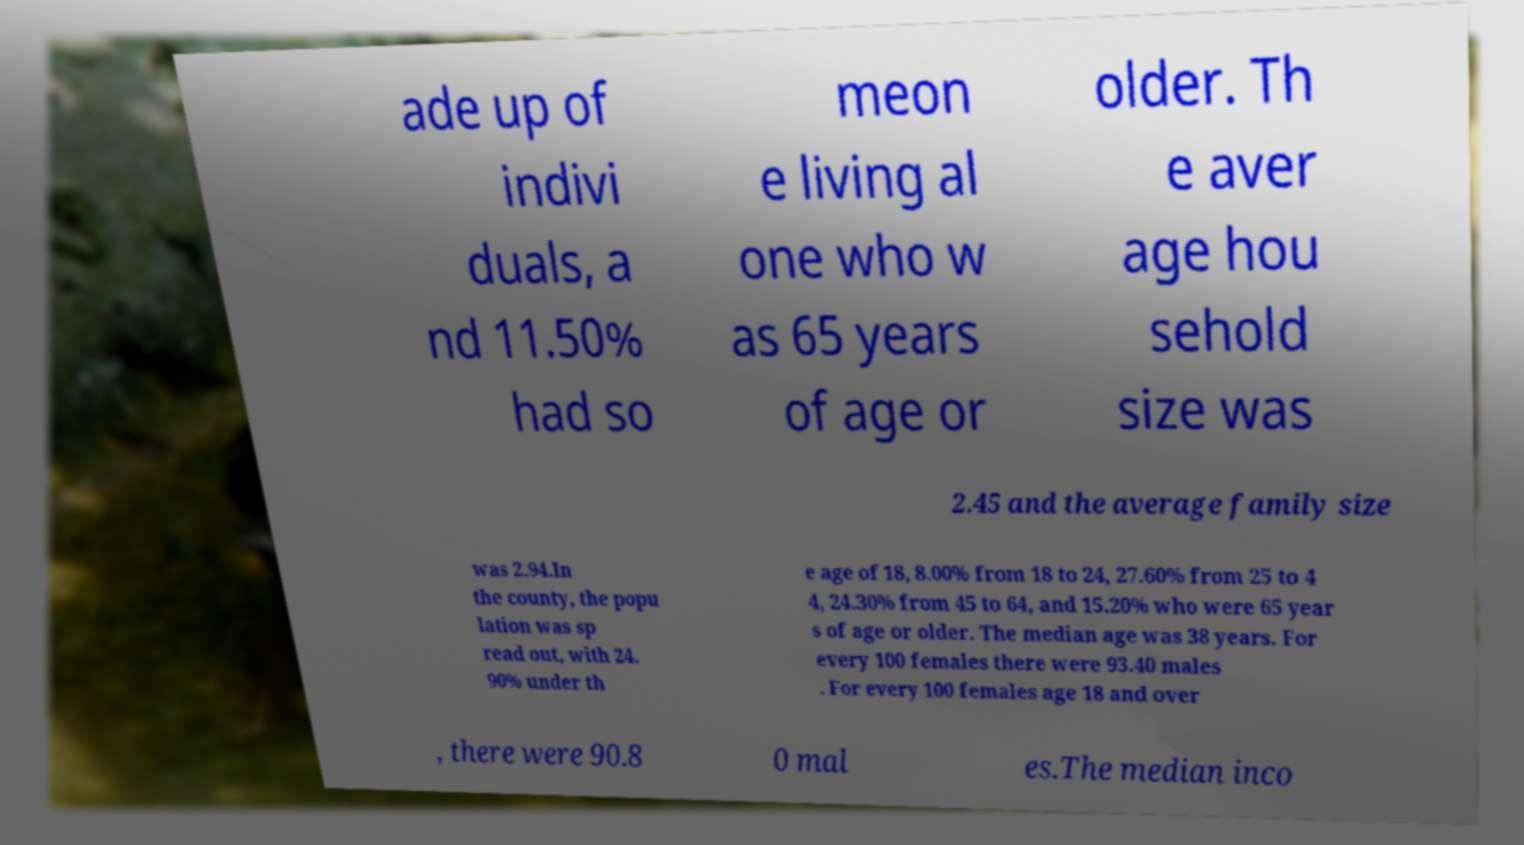What messages or text are displayed in this image? I need them in a readable, typed format. ade up of indivi duals, a nd 11.50% had so meon e living al one who w as 65 years of age or older. Th e aver age hou sehold size was 2.45 and the average family size was 2.94.In the county, the popu lation was sp read out, with 24. 90% under th e age of 18, 8.00% from 18 to 24, 27.60% from 25 to 4 4, 24.30% from 45 to 64, and 15.20% who were 65 year s of age or older. The median age was 38 years. For every 100 females there were 93.40 males . For every 100 females age 18 and over , there were 90.8 0 mal es.The median inco 